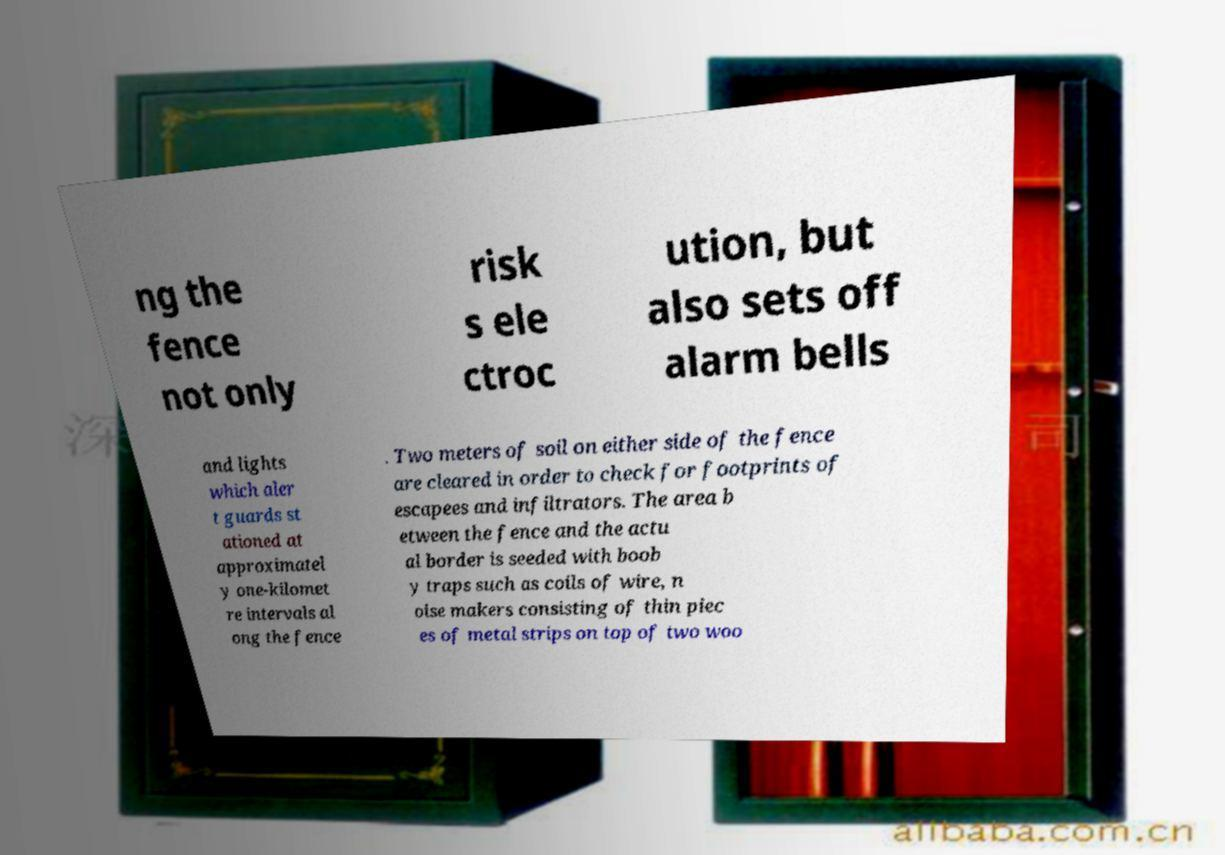I need the written content from this picture converted into text. Can you do that? ng the fence not only risk s ele ctroc ution, but also sets off alarm bells and lights which aler t guards st ationed at approximatel y one-kilomet re intervals al ong the fence . Two meters of soil on either side of the fence are cleared in order to check for footprints of escapees and infiltrators. The area b etween the fence and the actu al border is seeded with boob y traps such as coils of wire, n oise makers consisting of thin piec es of metal strips on top of two woo 